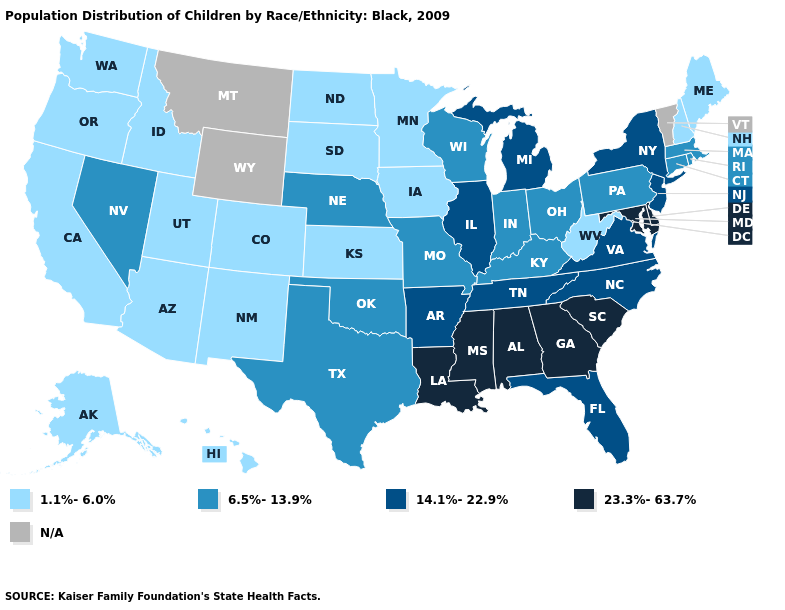What is the lowest value in the Northeast?
Quick response, please. 1.1%-6.0%. Name the states that have a value in the range N/A?
Give a very brief answer. Montana, Vermont, Wyoming. Which states hav the highest value in the South?
Short answer required. Alabama, Delaware, Georgia, Louisiana, Maryland, Mississippi, South Carolina. What is the highest value in the USA?
Keep it brief. 23.3%-63.7%. What is the value of New Mexico?
Quick response, please. 1.1%-6.0%. Name the states that have a value in the range 23.3%-63.7%?
Concise answer only. Alabama, Delaware, Georgia, Louisiana, Maryland, Mississippi, South Carolina. Which states have the lowest value in the West?
Keep it brief. Alaska, Arizona, California, Colorado, Hawaii, Idaho, New Mexico, Oregon, Utah, Washington. Name the states that have a value in the range 23.3%-63.7%?
Quick response, please. Alabama, Delaware, Georgia, Louisiana, Maryland, Mississippi, South Carolina. Which states hav the highest value in the Northeast?
Be succinct. New Jersey, New York. Which states hav the highest value in the South?
Short answer required. Alabama, Delaware, Georgia, Louisiana, Maryland, Mississippi, South Carolina. Name the states that have a value in the range 14.1%-22.9%?
Quick response, please. Arkansas, Florida, Illinois, Michigan, New Jersey, New York, North Carolina, Tennessee, Virginia. What is the value of New Jersey?
Give a very brief answer. 14.1%-22.9%. Among the states that border Ohio , which have the lowest value?
Concise answer only. West Virginia. Name the states that have a value in the range 14.1%-22.9%?
Keep it brief. Arkansas, Florida, Illinois, Michigan, New Jersey, New York, North Carolina, Tennessee, Virginia. What is the lowest value in states that border New Mexico?
Answer briefly. 1.1%-6.0%. 